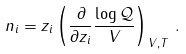<formula> <loc_0><loc_0><loc_500><loc_500>n _ { i } = z _ { i } \left ( \frac { \partial } { \partial z _ { i } } \frac { \log \mathcal { Q } } { V } \right ) _ { V , T } \, .</formula> 